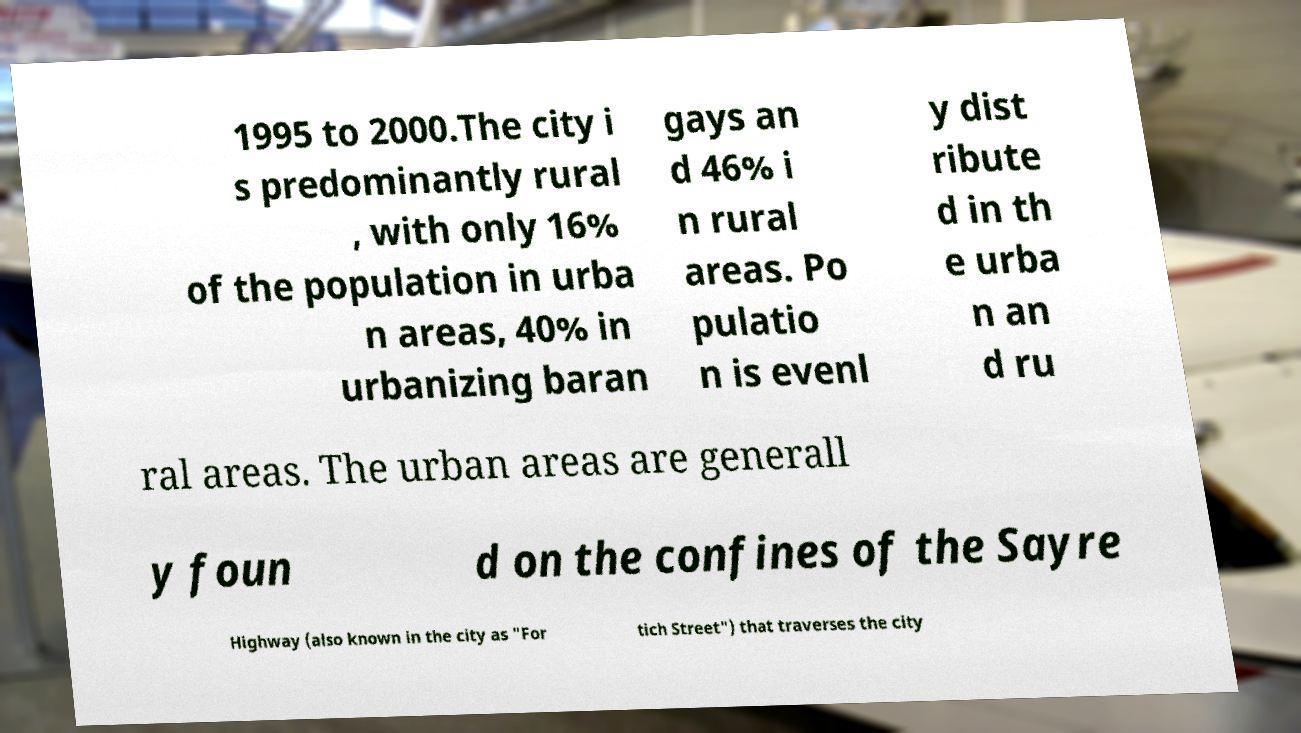I need the written content from this picture converted into text. Can you do that? 1995 to 2000.The city i s predominantly rural , with only 16% of the population in urba n areas, 40% in urbanizing baran gays an d 46% i n rural areas. Po pulatio n is evenl y dist ribute d in th e urba n an d ru ral areas. The urban areas are generall y foun d on the confines of the Sayre Highway (also known in the city as "For tich Street") that traverses the city 